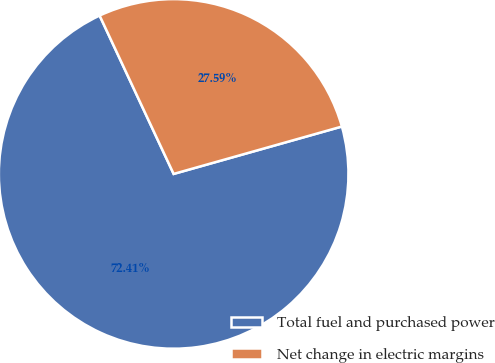Convert chart to OTSL. <chart><loc_0><loc_0><loc_500><loc_500><pie_chart><fcel>Total fuel and purchased power<fcel>Net change in electric margins<nl><fcel>72.41%<fcel>27.59%<nl></chart> 